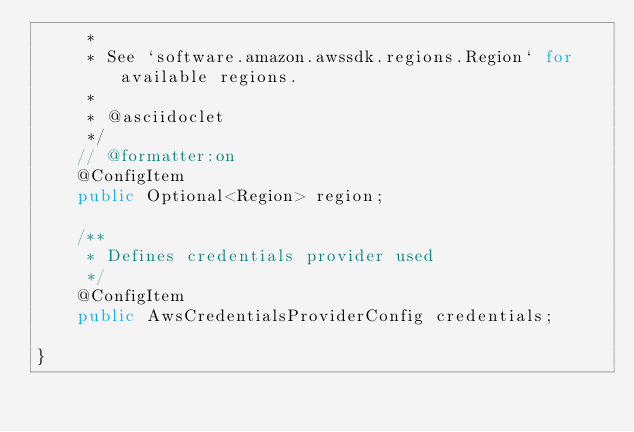<code> <loc_0><loc_0><loc_500><loc_500><_Java_>     *
     * See `software.amazon.awssdk.regions.Region` for available regions.
     * 
     * @asciidoclet
     */
    // @formatter:on
    @ConfigItem
    public Optional<Region> region;

    /**
     * Defines credentials provider used
     */
    @ConfigItem
    public AwsCredentialsProviderConfig credentials;

}
</code> 